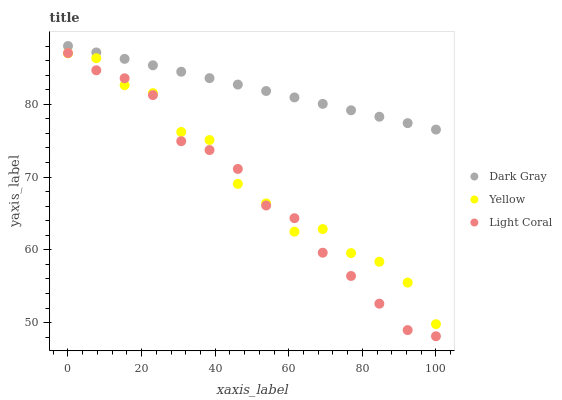Does Light Coral have the minimum area under the curve?
Answer yes or no. Yes. Does Dark Gray have the maximum area under the curve?
Answer yes or no. Yes. Does Yellow have the minimum area under the curve?
Answer yes or no. No. Does Yellow have the maximum area under the curve?
Answer yes or no. No. Is Dark Gray the smoothest?
Answer yes or no. Yes. Is Yellow the roughest?
Answer yes or no. Yes. Is Light Coral the smoothest?
Answer yes or no. No. Is Light Coral the roughest?
Answer yes or no. No. Does Light Coral have the lowest value?
Answer yes or no. Yes. Does Yellow have the lowest value?
Answer yes or no. No. Does Dark Gray have the highest value?
Answer yes or no. Yes. Does Light Coral have the highest value?
Answer yes or no. No. Is Yellow less than Dark Gray?
Answer yes or no. Yes. Is Dark Gray greater than Light Coral?
Answer yes or no. Yes. Does Light Coral intersect Yellow?
Answer yes or no. Yes. Is Light Coral less than Yellow?
Answer yes or no. No. Is Light Coral greater than Yellow?
Answer yes or no. No. Does Yellow intersect Dark Gray?
Answer yes or no. No. 